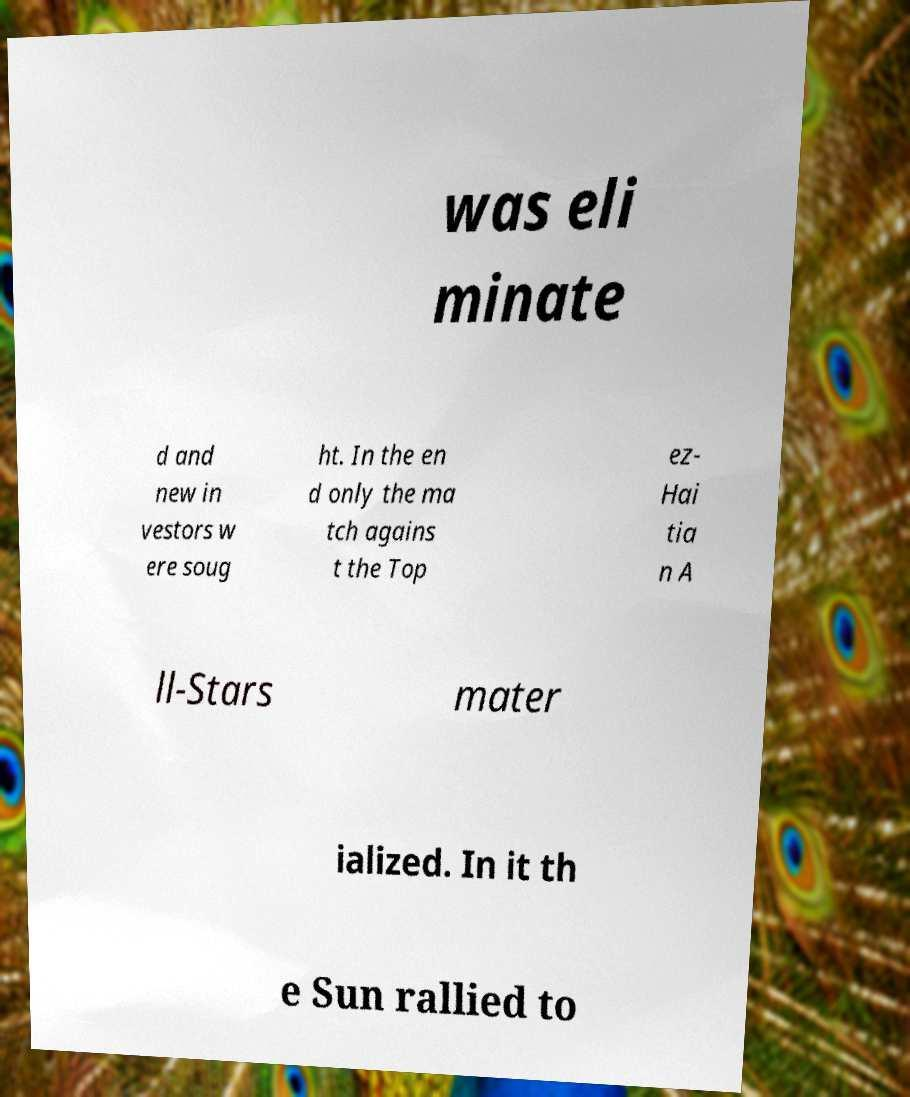For documentation purposes, I need the text within this image transcribed. Could you provide that? was eli minate d and new in vestors w ere soug ht. In the en d only the ma tch agains t the Top ez- Hai tia n A ll-Stars mater ialized. In it th e Sun rallied to 